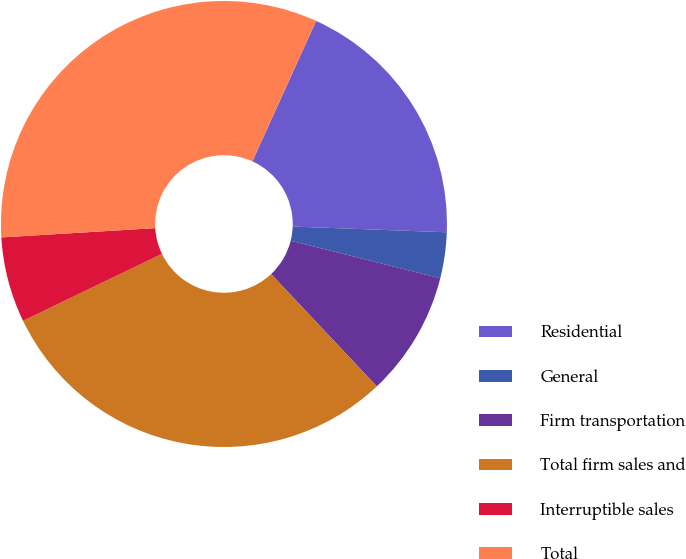Convert chart. <chart><loc_0><loc_0><loc_500><loc_500><pie_chart><fcel>Residential<fcel>General<fcel>Firm transportation<fcel>Total firm sales and<fcel>Interruptible sales<fcel>Total<nl><fcel>18.81%<fcel>3.32%<fcel>9.07%<fcel>29.87%<fcel>6.19%<fcel>32.74%<nl></chart> 